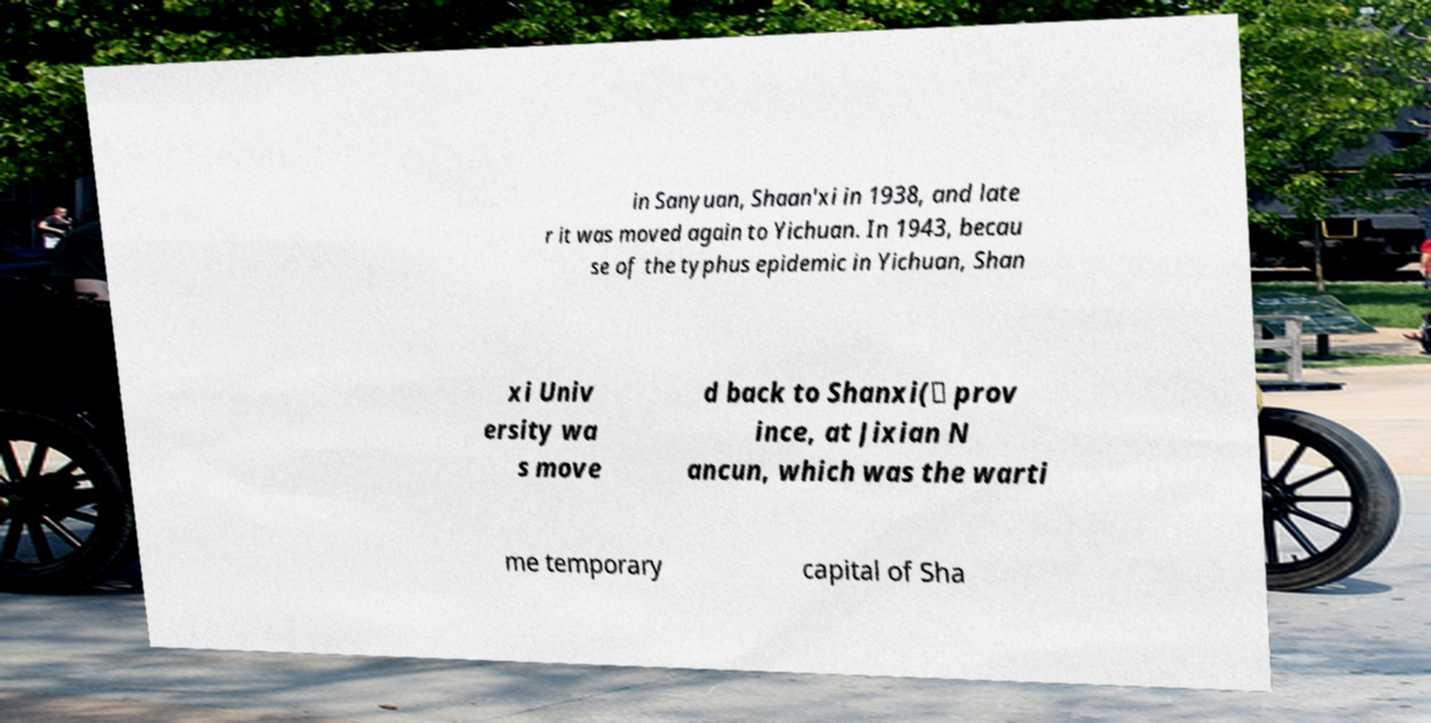What messages or text are displayed in this image? I need them in a readable, typed format. in Sanyuan, Shaan'xi in 1938, and late r it was moved again to Yichuan. In 1943, becau se of the typhus epidemic in Yichuan, Shan xi Univ ersity wa s move d back to Shanxi(） prov ince, at Jixian N ancun, which was the warti me temporary capital of Sha 